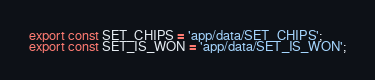Convert code to text. <code><loc_0><loc_0><loc_500><loc_500><_JavaScript_>export const SET_CHIPS = 'app/data/SET_CHIPS';
export const SET_IS_WON = 'app/data/SET_IS_WON';
</code> 